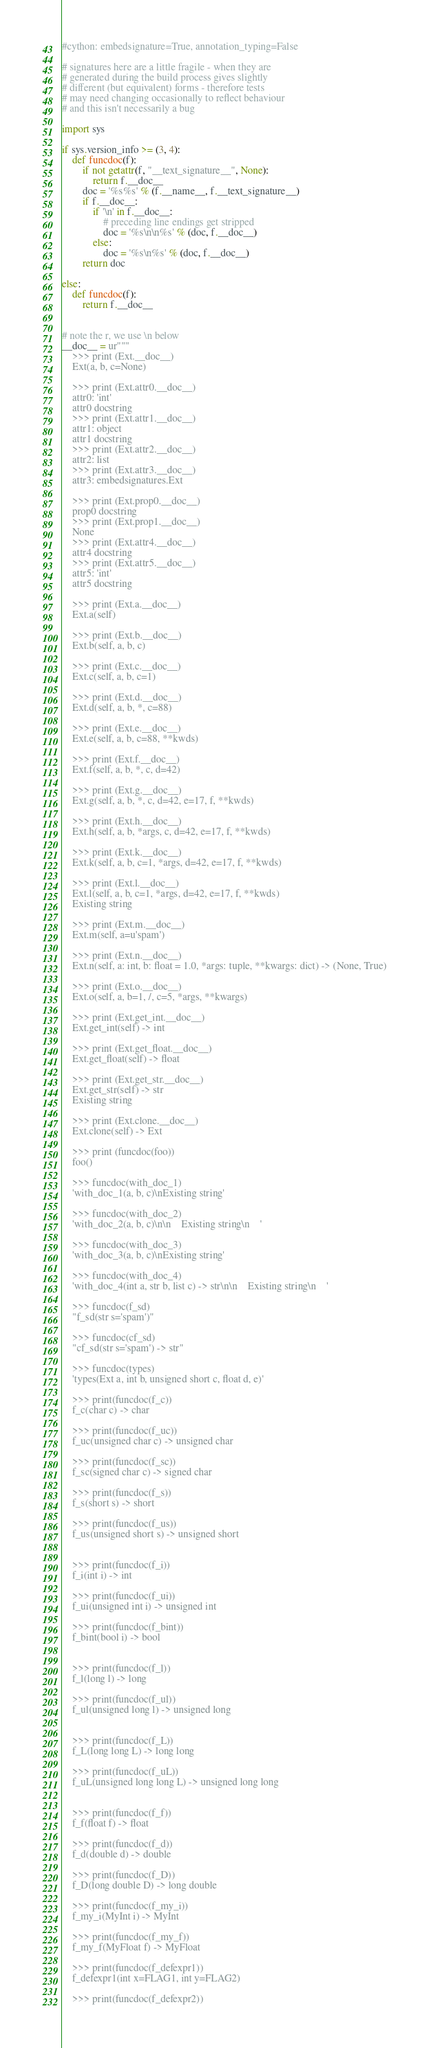<code> <loc_0><loc_0><loc_500><loc_500><_Cython_>#cython: embedsignature=True, annotation_typing=False

# signatures here are a little fragile - when they are
# generated during the build process gives slightly
# different (but equivalent) forms - therefore tests
# may need changing occasionally to reflect behaviour
# and this isn't necessarily a bug

import sys

if sys.version_info >= (3, 4):
    def funcdoc(f):
        if not getattr(f, "__text_signature__", None):
            return f.__doc__
        doc = '%s%s' % (f.__name__, f.__text_signature__)
        if f.__doc__:
            if '\n' in f.__doc__:
                # preceding line endings get stripped
                doc = '%s\n\n%s' % (doc, f.__doc__)
            else:
                doc = '%s\n%s' % (doc, f.__doc__)
        return doc

else:
    def funcdoc(f):
        return f.__doc__


# note the r, we use \n below
__doc__ = ur"""
    >>> print (Ext.__doc__)
    Ext(a, b, c=None)

    >>> print (Ext.attr0.__doc__)
    attr0: 'int'
    attr0 docstring
    >>> print (Ext.attr1.__doc__)
    attr1: object
    attr1 docstring
    >>> print (Ext.attr2.__doc__)
    attr2: list
    >>> print (Ext.attr3.__doc__)
    attr3: embedsignatures.Ext

    >>> print (Ext.prop0.__doc__)
    prop0 docstring
    >>> print (Ext.prop1.__doc__)
    None
    >>> print (Ext.attr4.__doc__)
    attr4 docstring
    >>> print (Ext.attr5.__doc__)
    attr5: 'int'
    attr5 docstring

    >>> print (Ext.a.__doc__)
    Ext.a(self)

    >>> print (Ext.b.__doc__)
    Ext.b(self, a, b, c)

    >>> print (Ext.c.__doc__)
    Ext.c(self, a, b, c=1)

    >>> print (Ext.d.__doc__)
    Ext.d(self, a, b, *, c=88)

    >>> print (Ext.e.__doc__)
    Ext.e(self, a, b, c=88, **kwds)

    >>> print (Ext.f.__doc__)
    Ext.f(self, a, b, *, c, d=42)

    >>> print (Ext.g.__doc__)
    Ext.g(self, a, b, *, c, d=42, e=17, f, **kwds)

    >>> print (Ext.h.__doc__)
    Ext.h(self, a, b, *args, c, d=42, e=17, f, **kwds)

    >>> print (Ext.k.__doc__)
    Ext.k(self, a, b, c=1, *args, d=42, e=17, f, **kwds)

    >>> print (Ext.l.__doc__)
    Ext.l(self, a, b, c=1, *args, d=42, e=17, f, **kwds)
    Existing string

    >>> print (Ext.m.__doc__)
    Ext.m(self, a=u'spam')

    >>> print (Ext.n.__doc__)
    Ext.n(self, a: int, b: float = 1.0, *args: tuple, **kwargs: dict) -> (None, True)

    >>> print (Ext.o.__doc__)
    Ext.o(self, a, b=1, /, c=5, *args, **kwargs)

    >>> print (Ext.get_int.__doc__)
    Ext.get_int(self) -> int

    >>> print (Ext.get_float.__doc__)
    Ext.get_float(self) -> float

    >>> print (Ext.get_str.__doc__)
    Ext.get_str(self) -> str
    Existing string

    >>> print (Ext.clone.__doc__)
    Ext.clone(self) -> Ext

    >>> print (funcdoc(foo))
    foo()

    >>> funcdoc(with_doc_1)
    'with_doc_1(a, b, c)\nExisting string'

    >>> funcdoc(with_doc_2)
    'with_doc_2(a, b, c)\n\n    Existing string\n    '

    >>> funcdoc(with_doc_3)
    'with_doc_3(a, b, c)\nExisting string'

    >>> funcdoc(with_doc_4)
    'with_doc_4(int a, str b, list c) -> str\n\n    Existing string\n    '

    >>> funcdoc(f_sd)
    "f_sd(str s='spam')"

    >>> funcdoc(cf_sd)
    "cf_sd(str s='spam') -> str"

    >>> funcdoc(types)
    'types(Ext a, int b, unsigned short c, float d, e)'

    >>> print(funcdoc(f_c))
    f_c(char c) -> char

    >>> print(funcdoc(f_uc))
    f_uc(unsigned char c) -> unsigned char

    >>> print(funcdoc(f_sc))
    f_sc(signed char c) -> signed char

    >>> print(funcdoc(f_s))
    f_s(short s) -> short

    >>> print(funcdoc(f_us))
    f_us(unsigned short s) -> unsigned short


    >>> print(funcdoc(f_i))
    f_i(int i) -> int

    >>> print(funcdoc(f_ui))
    f_ui(unsigned int i) -> unsigned int

    >>> print(funcdoc(f_bint))
    f_bint(bool i) -> bool


    >>> print(funcdoc(f_l))
    f_l(long l) -> long

    >>> print(funcdoc(f_ul))
    f_ul(unsigned long l) -> unsigned long


    >>> print(funcdoc(f_L))
    f_L(long long L) -> long long

    >>> print(funcdoc(f_uL))
    f_uL(unsigned long long L) -> unsigned long long


    >>> print(funcdoc(f_f))
    f_f(float f) -> float

    >>> print(funcdoc(f_d))
    f_d(double d) -> double

    >>> print(funcdoc(f_D))
    f_D(long double D) -> long double

    >>> print(funcdoc(f_my_i))
    f_my_i(MyInt i) -> MyInt

    >>> print(funcdoc(f_my_f))
    f_my_f(MyFloat f) -> MyFloat

    >>> print(funcdoc(f_defexpr1))
    f_defexpr1(int x=FLAG1, int y=FLAG2)

    >>> print(funcdoc(f_defexpr2))</code> 